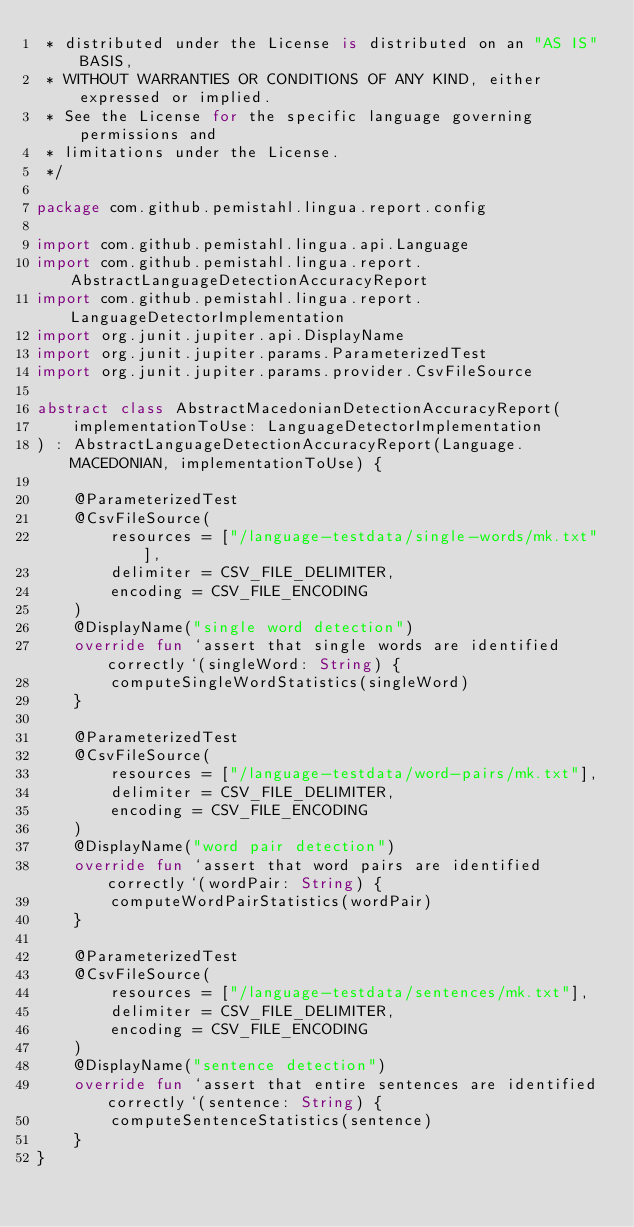Convert code to text. <code><loc_0><loc_0><loc_500><loc_500><_Kotlin_> * distributed under the License is distributed on an "AS IS" BASIS,
 * WITHOUT WARRANTIES OR CONDITIONS OF ANY KIND, either expressed or implied.
 * See the License for the specific language governing permissions and
 * limitations under the License.
 */

package com.github.pemistahl.lingua.report.config

import com.github.pemistahl.lingua.api.Language
import com.github.pemistahl.lingua.report.AbstractLanguageDetectionAccuracyReport
import com.github.pemistahl.lingua.report.LanguageDetectorImplementation
import org.junit.jupiter.api.DisplayName
import org.junit.jupiter.params.ParameterizedTest
import org.junit.jupiter.params.provider.CsvFileSource

abstract class AbstractMacedonianDetectionAccuracyReport(
    implementationToUse: LanguageDetectorImplementation
) : AbstractLanguageDetectionAccuracyReport(Language.MACEDONIAN, implementationToUse) {

    @ParameterizedTest
    @CsvFileSource(
        resources = ["/language-testdata/single-words/mk.txt"],
        delimiter = CSV_FILE_DELIMITER,
        encoding = CSV_FILE_ENCODING
    )
    @DisplayName("single word detection")
    override fun `assert that single words are identified correctly`(singleWord: String) {
        computeSingleWordStatistics(singleWord)
    }

    @ParameterizedTest
    @CsvFileSource(
        resources = ["/language-testdata/word-pairs/mk.txt"],
        delimiter = CSV_FILE_DELIMITER,
        encoding = CSV_FILE_ENCODING
    )
    @DisplayName("word pair detection")
    override fun `assert that word pairs are identified correctly`(wordPair: String) {
        computeWordPairStatistics(wordPair)
    }

    @ParameterizedTest
    @CsvFileSource(
        resources = ["/language-testdata/sentences/mk.txt"],
        delimiter = CSV_FILE_DELIMITER,
        encoding = CSV_FILE_ENCODING
    )
    @DisplayName("sentence detection")
    override fun `assert that entire sentences are identified correctly`(sentence: String) {
        computeSentenceStatistics(sentence)
    }
}
</code> 